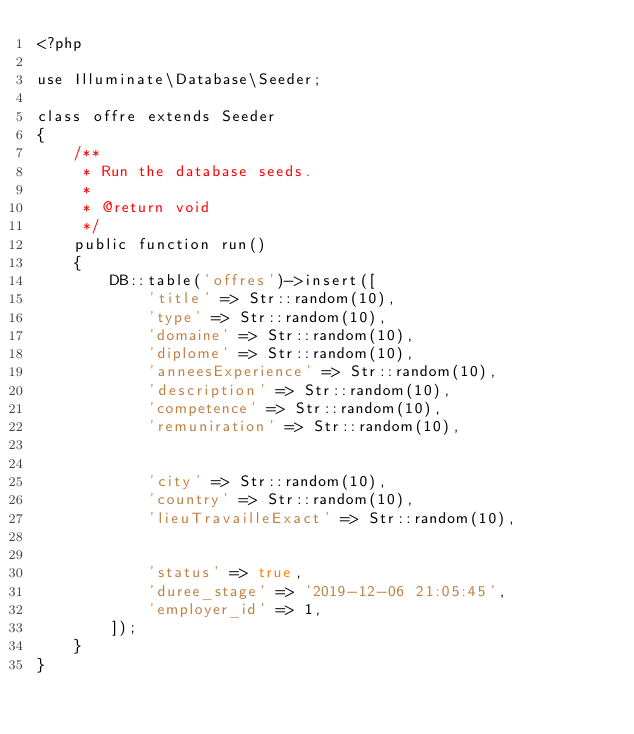<code> <loc_0><loc_0><loc_500><loc_500><_PHP_><?php

use Illuminate\Database\Seeder;

class offre extends Seeder
{
    /**
     * Run the database seeds.
     *
     * @return void
     */
    public function run()
    {
        DB::table('offres')->insert([
            'title' => Str::random(10),
            'type' => Str::random(10),
            'domaine' => Str::random(10),
            'diplome' => Str::random(10),
            'anneesExperience' => Str::random(10),
            'description' => Str::random(10),
            'competence' => Str::random(10),
            'remuniration' => Str::random(10),


            'city' => Str::random(10),
            'country' => Str::random(10),
            'lieuTravailleExact' => Str::random(10),


            'status' => true,
            'duree_stage' => '2019-12-06 21:05:45',
            'employer_id' => 1,
        ]);
    }
}
</code> 